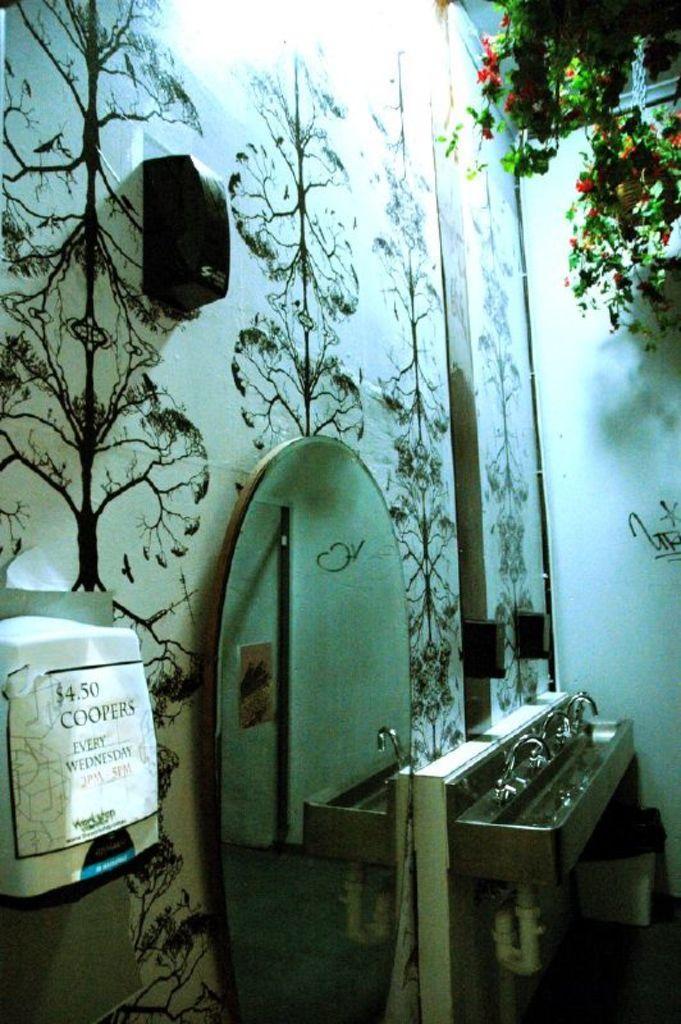Describe this image in one or two sentences. This image is taken indoors. On the right side of the image there are a few plants in the pots. On the left side of the image there is a wall and there is a tissue holder. There is a mirror on the wall. There is a sink with a few taps. 